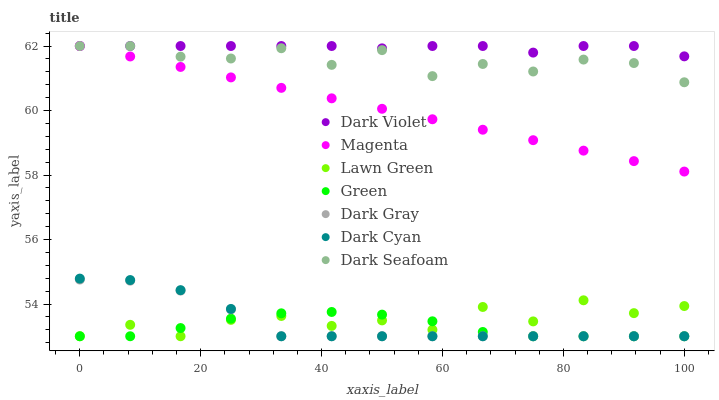Does Green have the minimum area under the curve?
Answer yes or no. Yes. Does Dark Violet have the maximum area under the curve?
Answer yes or no. Yes. Does Dark Gray have the minimum area under the curve?
Answer yes or no. No. Does Dark Gray have the maximum area under the curve?
Answer yes or no. No. Is Magenta the smoothest?
Answer yes or no. Yes. Is Lawn Green the roughest?
Answer yes or no. Yes. Is Dark Violet the smoothest?
Answer yes or no. No. Is Dark Violet the roughest?
Answer yes or no. No. Does Lawn Green have the lowest value?
Answer yes or no. Yes. Does Dark Violet have the lowest value?
Answer yes or no. No. Does Magenta have the highest value?
Answer yes or no. Yes. Does Dark Gray have the highest value?
Answer yes or no. No. Is Dark Gray less than Dark Violet?
Answer yes or no. Yes. Is Magenta greater than Dark Cyan?
Answer yes or no. Yes. Does Green intersect Dark Cyan?
Answer yes or no. Yes. Is Green less than Dark Cyan?
Answer yes or no. No. Is Green greater than Dark Cyan?
Answer yes or no. No. Does Dark Gray intersect Dark Violet?
Answer yes or no. No. 